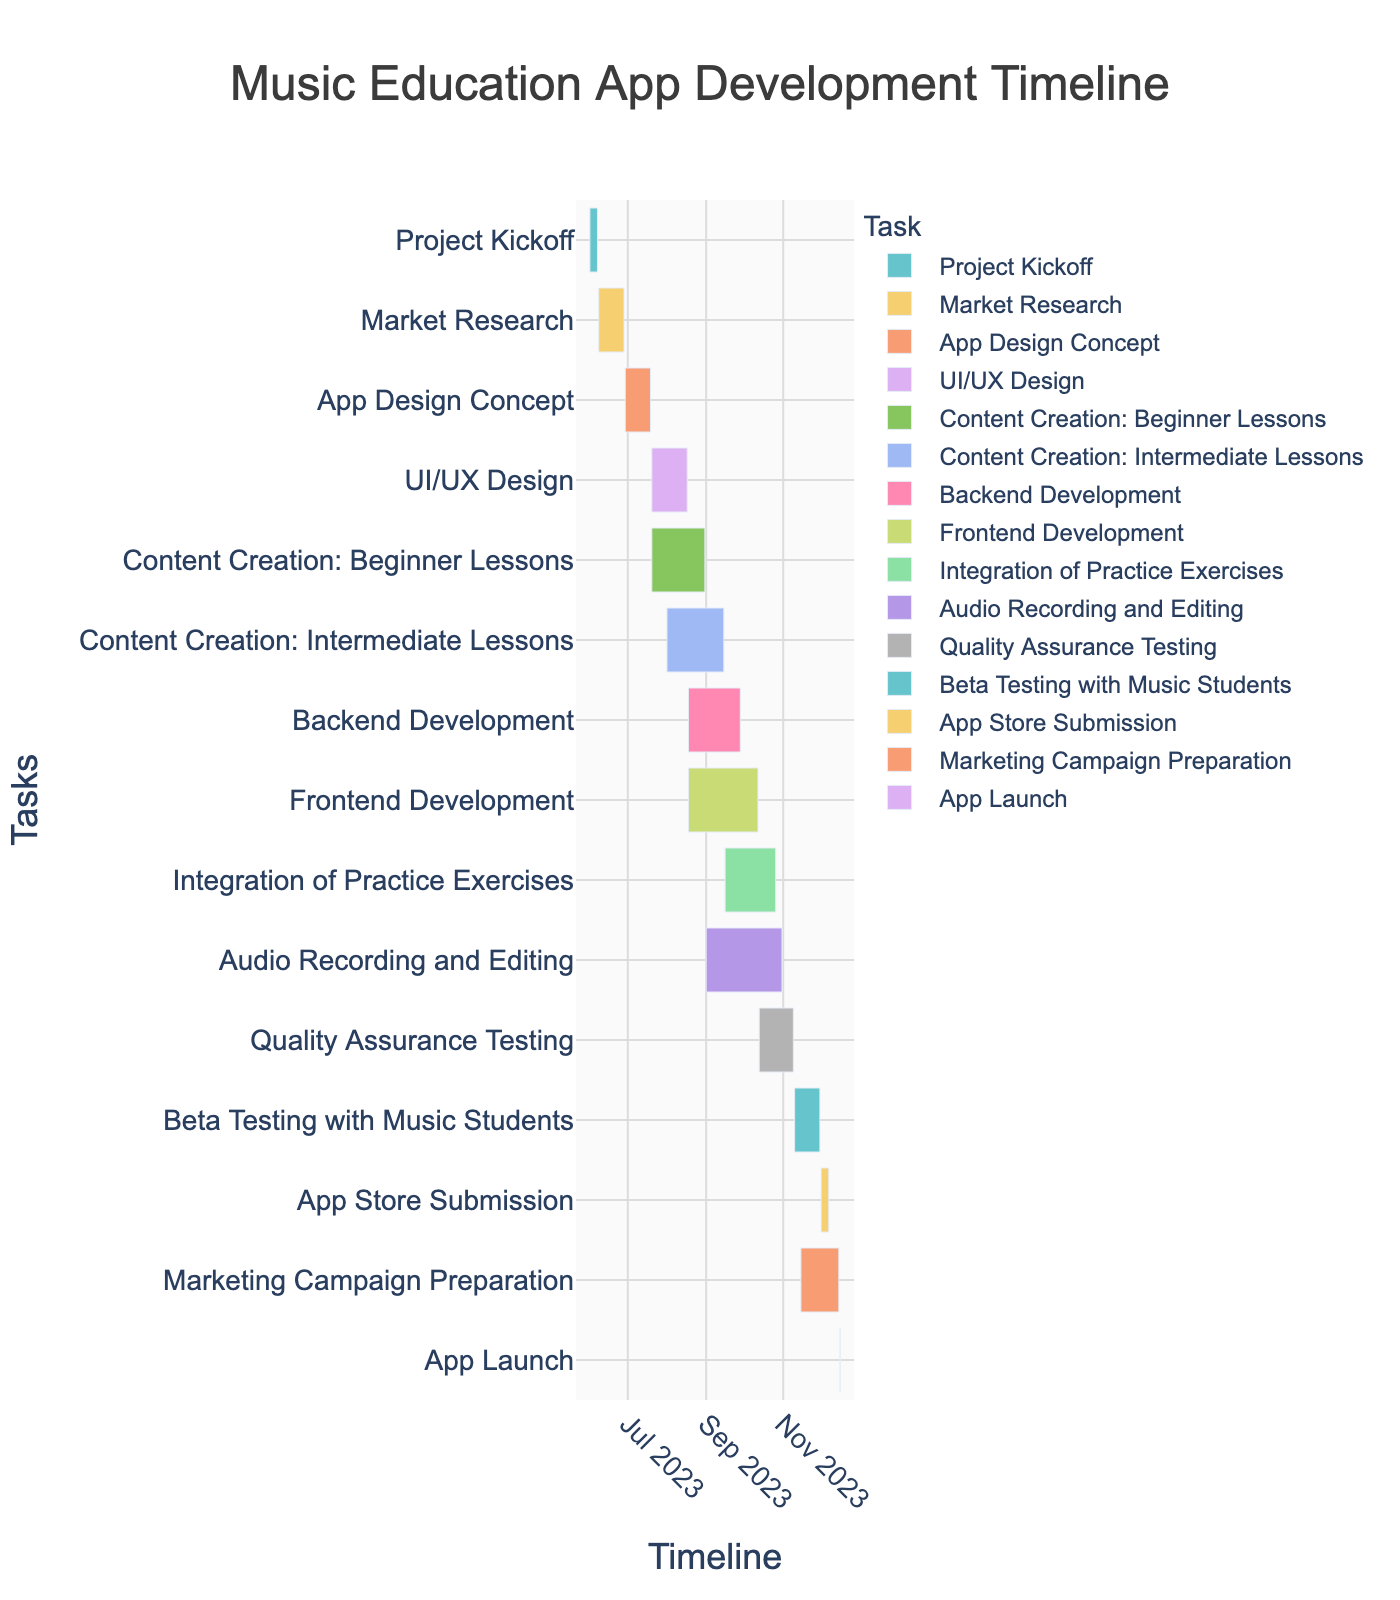What is the duration of the Market Research task? Look at the Market Research task on the Gantt chart. According to the provided data, it runs from June 8, 2023, to June 28, 2023, which is a total duration of 21 days.
Answer: 21 days Which task has the longest duration? Examine the Gantt chart for the duration of each task. The task with the longest bar in the timeline is "Audio Recording and Editing," which spans from September 1, 2023, to October 31, 2023, totaling 61 days.
Answer: Audio Recording and Editing What tasks are being carried out simultaneously with Backend Development? Find the Backend Development task on the Gantt chart, which runs from August 18, 2023, to September 28, 2023. The simultaneous tasks include Frontend Development (August 18, 2023 - October 12, 2023), Content Creation: Intermediate Lessons (August 1, 2023 - September 15, 2023), and Audio Recording and Editing (September 1, 2023 - October 31, 2023).
Answer: Frontend Development, Content Creation: Intermediate Lessons, Audio Recording and Editing When does the Integration of Practice Exercises begin and end? Locate the Integration of Practice Exercises task on the Gantt chart. According to the provided data, it starts on September 16, 2023, and ends on October 26, 2023.
Answer: Starts: September 16, 2023, Ends: October 26, 2023 What is the combined duration of the tasks that start in June? Identify the tasks that start in June: Project Kickoff (7 days), Market Research (21 days), and App Design Concept (21 days). Sum their durations: 7 + 21 + 21 = 49 days.
Answer: 49 days Which tasks overlap with the Beta Testing with Music Students task? The Beta Testing with Music Students task runs from November 10, 2023, to November 30, 2023. Overlapping tasks are Quality Assurance Testing (October 13, 2023 - November 9, 2023), App Store Submission (December 1, 2023 - December 7, 2023), and Marketing Campaign Preparation (November 15, 2023 - December 15, 2023).
Answer: Marketing Campaign Preparation What is the shortest task, and how long does it last? The shortest task is the App Launch, lasting only 1 day on December 16, 2023.
Answer: App Launch, 1 day How many tasks are scheduled to end in October 2023? Look at the end dates on the Gantt chart for October 2023. The tasks ending in October are Frontend Development (October 12, 2023), Integration of Practice Exercises (October 26, 2023), and Audio Recording and Editing (October 31, 2023).
Answer: 3 tasks Which task directly follows the Quality Assurance Testing? Identify the Quality Assurance Testing task ending on November 9, 2023. The next task starting on November 10, 2023, is Beta Testing with Music Students.
Answer: Beta Testing with Music Students 